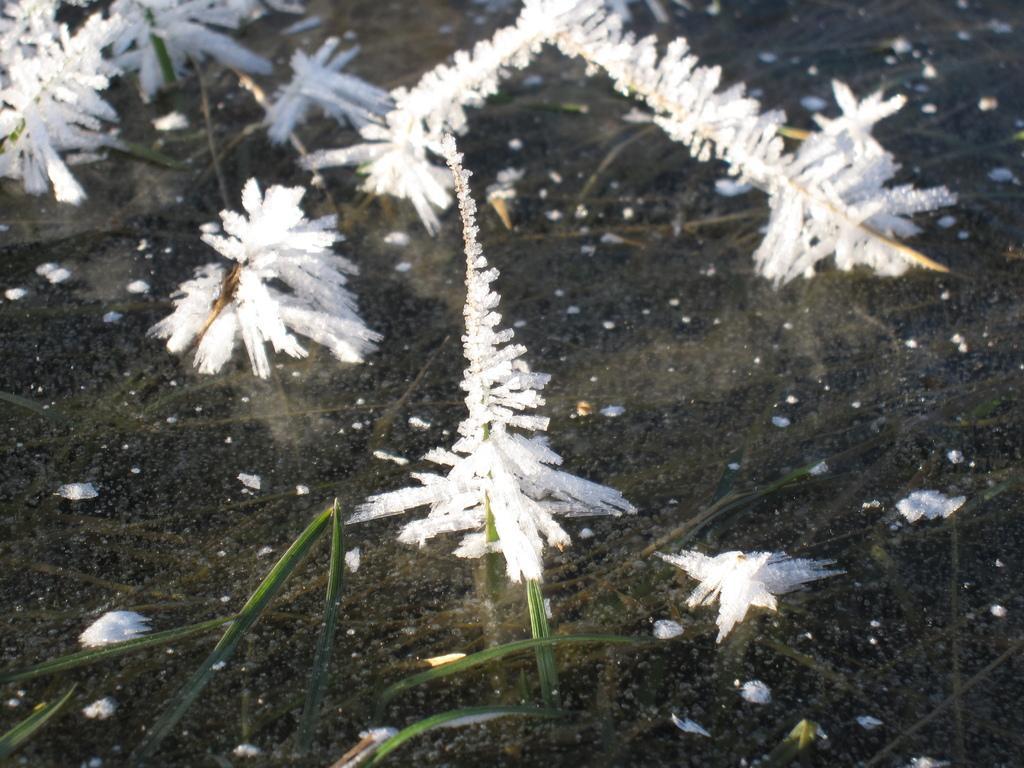Can you describe this image briefly? In this picture we can see the grass covered by ice. In the background of the image we can see the water. 